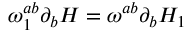<formula> <loc_0><loc_0><loc_500><loc_500>\omega _ { 1 } ^ { a b } \partial _ { b } H = \omega ^ { a b } \partial _ { b } H _ { 1 }</formula> 